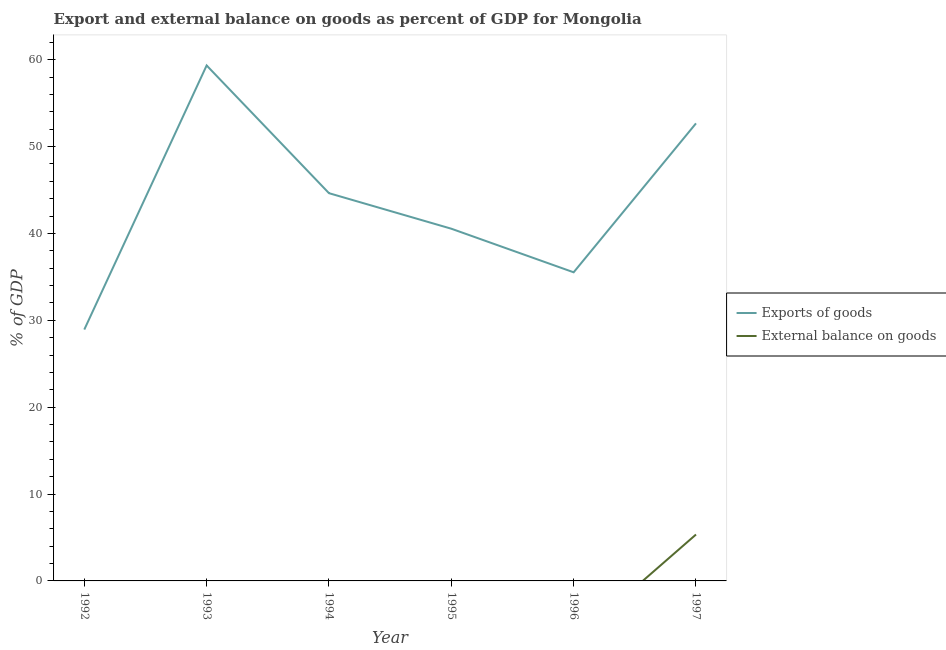Is the number of lines equal to the number of legend labels?
Your response must be concise. No. What is the external balance on goods as percentage of gdp in 1993?
Provide a succinct answer. 0. Across all years, what is the maximum export of goods as percentage of gdp?
Your response must be concise. 59.33. Across all years, what is the minimum export of goods as percentage of gdp?
Keep it short and to the point. 28.93. In which year was the external balance on goods as percentage of gdp maximum?
Give a very brief answer. 1997. What is the total export of goods as percentage of gdp in the graph?
Your answer should be compact. 261.63. What is the difference between the export of goods as percentage of gdp in 1994 and that in 1996?
Give a very brief answer. 9.11. What is the difference between the external balance on goods as percentage of gdp in 1992 and the export of goods as percentage of gdp in 1993?
Keep it short and to the point. -59.33. What is the average external balance on goods as percentage of gdp per year?
Give a very brief answer. 0.89. In the year 1997, what is the difference between the external balance on goods as percentage of gdp and export of goods as percentage of gdp?
Offer a very short reply. -47.33. What is the ratio of the export of goods as percentage of gdp in 1995 to that in 1997?
Give a very brief answer. 0.77. Is the export of goods as percentage of gdp in 1993 less than that in 1995?
Your answer should be compact. No. What is the difference between the highest and the second highest export of goods as percentage of gdp?
Provide a short and direct response. 6.67. What is the difference between the highest and the lowest external balance on goods as percentage of gdp?
Ensure brevity in your answer.  5.34. In how many years, is the external balance on goods as percentage of gdp greater than the average external balance on goods as percentage of gdp taken over all years?
Your response must be concise. 1. Is the sum of the export of goods as percentage of gdp in 1993 and 1995 greater than the maximum external balance on goods as percentage of gdp across all years?
Keep it short and to the point. Yes. Is the export of goods as percentage of gdp strictly greater than the external balance on goods as percentage of gdp over the years?
Give a very brief answer. Yes. What is the difference between two consecutive major ticks on the Y-axis?
Your response must be concise. 10. Are the values on the major ticks of Y-axis written in scientific E-notation?
Give a very brief answer. No. Does the graph contain any zero values?
Your answer should be compact. Yes. Where does the legend appear in the graph?
Offer a very short reply. Center right. How many legend labels are there?
Offer a terse response. 2. How are the legend labels stacked?
Provide a short and direct response. Vertical. What is the title of the graph?
Give a very brief answer. Export and external balance on goods as percent of GDP for Mongolia. Does "Lowest 10% of population" appear as one of the legend labels in the graph?
Make the answer very short. No. What is the label or title of the X-axis?
Make the answer very short. Year. What is the label or title of the Y-axis?
Your answer should be very brief. % of GDP. What is the % of GDP of Exports of goods in 1992?
Your response must be concise. 28.93. What is the % of GDP of External balance on goods in 1992?
Offer a very short reply. 0. What is the % of GDP in Exports of goods in 1993?
Offer a very short reply. 59.33. What is the % of GDP of Exports of goods in 1994?
Your answer should be very brief. 44.63. What is the % of GDP of External balance on goods in 1994?
Your answer should be very brief. 0. What is the % of GDP of Exports of goods in 1995?
Ensure brevity in your answer.  40.54. What is the % of GDP in Exports of goods in 1996?
Offer a very short reply. 35.52. What is the % of GDP in Exports of goods in 1997?
Offer a very short reply. 52.67. What is the % of GDP of External balance on goods in 1997?
Make the answer very short. 5.34. Across all years, what is the maximum % of GDP of Exports of goods?
Keep it short and to the point. 59.33. Across all years, what is the maximum % of GDP of External balance on goods?
Give a very brief answer. 5.34. Across all years, what is the minimum % of GDP of Exports of goods?
Offer a terse response. 28.93. Across all years, what is the minimum % of GDP in External balance on goods?
Give a very brief answer. 0. What is the total % of GDP in Exports of goods in the graph?
Ensure brevity in your answer.  261.63. What is the total % of GDP of External balance on goods in the graph?
Ensure brevity in your answer.  5.34. What is the difference between the % of GDP in Exports of goods in 1992 and that in 1993?
Your answer should be very brief. -30.4. What is the difference between the % of GDP of Exports of goods in 1992 and that in 1994?
Provide a short and direct response. -15.7. What is the difference between the % of GDP of Exports of goods in 1992 and that in 1995?
Offer a very short reply. -11.61. What is the difference between the % of GDP of Exports of goods in 1992 and that in 1996?
Make the answer very short. -6.59. What is the difference between the % of GDP in Exports of goods in 1992 and that in 1997?
Make the answer very short. -23.73. What is the difference between the % of GDP in Exports of goods in 1993 and that in 1994?
Offer a very short reply. 14.7. What is the difference between the % of GDP in Exports of goods in 1993 and that in 1995?
Make the answer very short. 18.79. What is the difference between the % of GDP of Exports of goods in 1993 and that in 1996?
Offer a very short reply. 23.81. What is the difference between the % of GDP in Exports of goods in 1993 and that in 1997?
Your response must be concise. 6.67. What is the difference between the % of GDP of Exports of goods in 1994 and that in 1995?
Provide a succinct answer. 4.09. What is the difference between the % of GDP in Exports of goods in 1994 and that in 1996?
Provide a succinct answer. 9.11. What is the difference between the % of GDP in Exports of goods in 1994 and that in 1997?
Give a very brief answer. -8.04. What is the difference between the % of GDP in Exports of goods in 1995 and that in 1996?
Your response must be concise. 5.02. What is the difference between the % of GDP of Exports of goods in 1995 and that in 1997?
Ensure brevity in your answer.  -12.12. What is the difference between the % of GDP in Exports of goods in 1996 and that in 1997?
Keep it short and to the point. -17.14. What is the difference between the % of GDP of Exports of goods in 1992 and the % of GDP of External balance on goods in 1997?
Your answer should be very brief. 23.59. What is the difference between the % of GDP in Exports of goods in 1993 and the % of GDP in External balance on goods in 1997?
Offer a terse response. 53.99. What is the difference between the % of GDP of Exports of goods in 1994 and the % of GDP of External balance on goods in 1997?
Offer a terse response. 39.29. What is the difference between the % of GDP of Exports of goods in 1995 and the % of GDP of External balance on goods in 1997?
Provide a short and direct response. 35.2. What is the difference between the % of GDP of Exports of goods in 1996 and the % of GDP of External balance on goods in 1997?
Provide a short and direct response. 30.18. What is the average % of GDP in Exports of goods per year?
Provide a succinct answer. 43.6. What is the average % of GDP of External balance on goods per year?
Your answer should be compact. 0.89. In the year 1997, what is the difference between the % of GDP in Exports of goods and % of GDP in External balance on goods?
Your answer should be very brief. 47.33. What is the ratio of the % of GDP of Exports of goods in 1992 to that in 1993?
Provide a succinct answer. 0.49. What is the ratio of the % of GDP of Exports of goods in 1992 to that in 1994?
Provide a succinct answer. 0.65. What is the ratio of the % of GDP of Exports of goods in 1992 to that in 1995?
Your response must be concise. 0.71. What is the ratio of the % of GDP in Exports of goods in 1992 to that in 1996?
Give a very brief answer. 0.81. What is the ratio of the % of GDP of Exports of goods in 1992 to that in 1997?
Keep it short and to the point. 0.55. What is the ratio of the % of GDP of Exports of goods in 1993 to that in 1994?
Your answer should be compact. 1.33. What is the ratio of the % of GDP in Exports of goods in 1993 to that in 1995?
Keep it short and to the point. 1.46. What is the ratio of the % of GDP in Exports of goods in 1993 to that in 1996?
Give a very brief answer. 1.67. What is the ratio of the % of GDP in Exports of goods in 1993 to that in 1997?
Your response must be concise. 1.13. What is the ratio of the % of GDP of Exports of goods in 1994 to that in 1995?
Keep it short and to the point. 1.1. What is the ratio of the % of GDP in Exports of goods in 1994 to that in 1996?
Keep it short and to the point. 1.26. What is the ratio of the % of GDP of Exports of goods in 1994 to that in 1997?
Keep it short and to the point. 0.85. What is the ratio of the % of GDP in Exports of goods in 1995 to that in 1996?
Provide a short and direct response. 1.14. What is the ratio of the % of GDP in Exports of goods in 1995 to that in 1997?
Offer a very short reply. 0.77. What is the ratio of the % of GDP in Exports of goods in 1996 to that in 1997?
Keep it short and to the point. 0.67. What is the difference between the highest and the second highest % of GDP of Exports of goods?
Offer a very short reply. 6.67. What is the difference between the highest and the lowest % of GDP of Exports of goods?
Offer a terse response. 30.4. What is the difference between the highest and the lowest % of GDP of External balance on goods?
Provide a short and direct response. 5.34. 